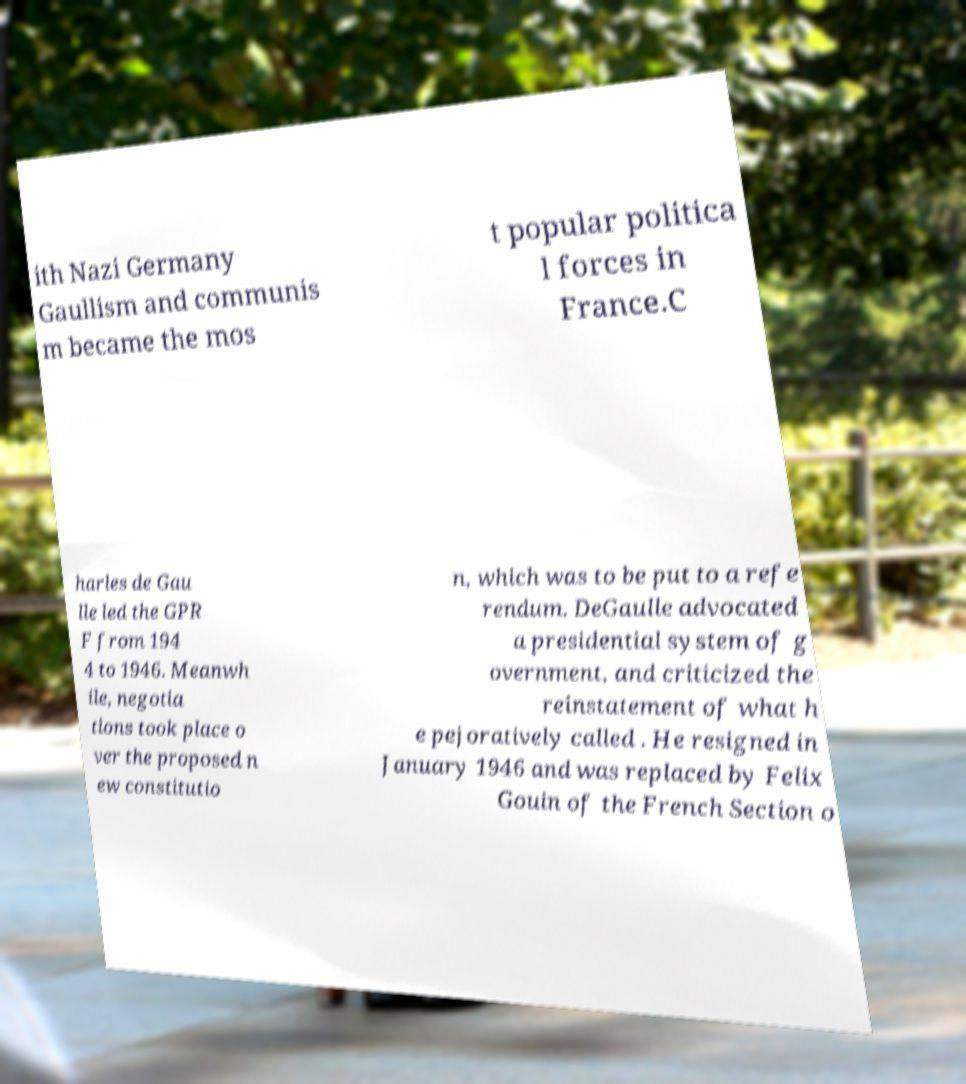Can you accurately transcribe the text from the provided image for me? ith Nazi Germany Gaullism and communis m became the mos t popular politica l forces in France.C harles de Gau lle led the GPR F from 194 4 to 1946. Meanwh ile, negotia tions took place o ver the proposed n ew constitutio n, which was to be put to a refe rendum. DeGaulle advocated a presidential system of g overnment, and criticized the reinstatement of what h e pejoratively called . He resigned in January 1946 and was replaced by Felix Gouin of the French Section o 